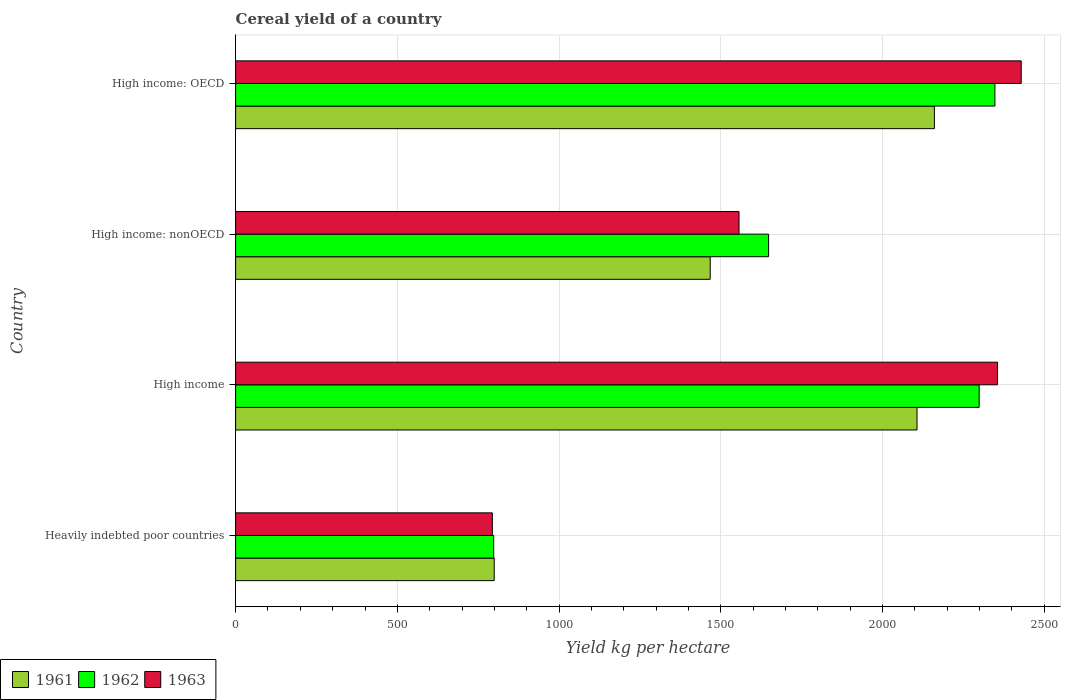How many different coloured bars are there?
Offer a terse response. 3. How many groups of bars are there?
Make the answer very short. 4. How many bars are there on the 1st tick from the top?
Provide a short and direct response. 3. How many bars are there on the 1st tick from the bottom?
Keep it short and to the point. 3. What is the label of the 4th group of bars from the top?
Offer a terse response. Heavily indebted poor countries. What is the total cereal yield in 1963 in High income?
Your response must be concise. 2355.41. Across all countries, what is the maximum total cereal yield in 1962?
Your answer should be very brief. 2347.24. Across all countries, what is the minimum total cereal yield in 1962?
Give a very brief answer. 797.81. In which country was the total cereal yield in 1962 maximum?
Keep it short and to the point. High income: OECD. In which country was the total cereal yield in 1963 minimum?
Make the answer very short. Heavily indebted poor countries. What is the total total cereal yield in 1963 in the graph?
Your answer should be compact. 7133.8. What is the difference between the total cereal yield in 1962 in Heavily indebted poor countries and that in High income?
Give a very brief answer. -1500.72. What is the difference between the total cereal yield in 1963 in High income and the total cereal yield in 1962 in High income: nonOECD?
Ensure brevity in your answer.  707.8. What is the average total cereal yield in 1961 per country?
Keep it short and to the point. 1633.28. What is the difference between the total cereal yield in 1963 and total cereal yield in 1961 in High income: OECD?
Your answer should be compact. 268.36. In how many countries, is the total cereal yield in 1962 greater than 2000 kg per hectare?
Make the answer very short. 2. What is the ratio of the total cereal yield in 1962 in Heavily indebted poor countries to that in High income: nonOECD?
Make the answer very short. 0.48. Is the difference between the total cereal yield in 1963 in High income: OECD and High income: nonOECD greater than the difference between the total cereal yield in 1961 in High income: OECD and High income: nonOECD?
Keep it short and to the point. Yes. What is the difference between the highest and the second highest total cereal yield in 1963?
Provide a short and direct response. 73.14. What is the difference between the highest and the lowest total cereal yield in 1963?
Provide a short and direct response. 1634.89. Are the values on the major ticks of X-axis written in scientific E-notation?
Ensure brevity in your answer.  No. Where does the legend appear in the graph?
Provide a succinct answer. Bottom left. How many legend labels are there?
Your response must be concise. 3. What is the title of the graph?
Your answer should be compact. Cereal yield of a country. Does "1962" appear as one of the legend labels in the graph?
Offer a terse response. Yes. What is the label or title of the X-axis?
Make the answer very short. Yield kg per hectare. What is the Yield kg per hectare in 1961 in Heavily indebted poor countries?
Offer a very short reply. 799.37. What is the Yield kg per hectare of 1962 in Heavily indebted poor countries?
Offer a very short reply. 797.81. What is the Yield kg per hectare in 1963 in Heavily indebted poor countries?
Ensure brevity in your answer.  793.65. What is the Yield kg per hectare of 1961 in High income?
Offer a terse response. 2106.44. What is the Yield kg per hectare in 1962 in High income?
Provide a short and direct response. 2298.54. What is the Yield kg per hectare in 1963 in High income?
Ensure brevity in your answer.  2355.41. What is the Yield kg per hectare of 1961 in High income: nonOECD?
Provide a succinct answer. 1467.13. What is the Yield kg per hectare in 1962 in High income: nonOECD?
Provide a succinct answer. 1647.61. What is the Yield kg per hectare of 1963 in High income: nonOECD?
Your answer should be compact. 1556.2. What is the Yield kg per hectare in 1961 in High income: OECD?
Ensure brevity in your answer.  2160.18. What is the Yield kg per hectare in 1962 in High income: OECD?
Your answer should be compact. 2347.24. What is the Yield kg per hectare in 1963 in High income: OECD?
Give a very brief answer. 2428.54. Across all countries, what is the maximum Yield kg per hectare of 1961?
Your answer should be compact. 2160.18. Across all countries, what is the maximum Yield kg per hectare of 1962?
Your response must be concise. 2347.24. Across all countries, what is the maximum Yield kg per hectare of 1963?
Make the answer very short. 2428.54. Across all countries, what is the minimum Yield kg per hectare in 1961?
Your answer should be very brief. 799.37. Across all countries, what is the minimum Yield kg per hectare of 1962?
Provide a short and direct response. 797.81. Across all countries, what is the minimum Yield kg per hectare of 1963?
Give a very brief answer. 793.65. What is the total Yield kg per hectare in 1961 in the graph?
Provide a short and direct response. 6533.12. What is the total Yield kg per hectare in 1962 in the graph?
Provide a succinct answer. 7091.2. What is the total Yield kg per hectare in 1963 in the graph?
Your response must be concise. 7133.8. What is the difference between the Yield kg per hectare in 1961 in Heavily indebted poor countries and that in High income?
Give a very brief answer. -1307.07. What is the difference between the Yield kg per hectare of 1962 in Heavily indebted poor countries and that in High income?
Your answer should be very brief. -1500.72. What is the difference between the Yield kg per hectare in 1963 in Heavily indebted poor countries and that in High income?
Your answer should be compact. -1561.76. What is the difference between the Yield kg per hectare of 1961 in Heavily indebted poor countries and that in High income: nonOECD?
Provide a short and direct response. -667.76. What is the difference between the Yield kg per hectare in 1962 in Heavily indebted poor countries and that in High income: nonOECD?
Provide a succinct answer. -849.8. What is the difference between the Yield kg per hectare of 1963 in Heavily indebted poor countries and that in High income: nonOECD?
Provide a succinct answer. -762.55. What is the difference between the Yield kg per hectare in 1961 in Heavily indebted poor countries and that in High income: OECD?
Offer a very short reply. -1360.81. What is the difference between the Yield kg per hectare of 1962 in Heavily indebted poor countries and that in High income: OECD?
Make the answer very short. -1549.43. What is the difference between the Yield kg per hectare in 1963 in Heavily indebted poor countries and that in High income: OECD?
Your answer should be very brief. -1634.89. What is the difference between the Yield kg per hectare in 1961 in High income and that in High income: nonOECD?
Keep it short and to the point. 639.31. What is the difference between the Yield kg per hectare in 1962 in High income and that in High income: nonOECD?
Ensure brevity in your answer.  650.93. What is the difference between the Yield kg per hectare in 1963 in High income and that in High income: nonOECD?
Give a very brief answer. 799.2. What is the difference between the Yield kg per hectare of 1961 in High income and that in High income: OECD?
Give a very brief answer. -53.74. What is the difference between the Yield kg per hectare of 1962 in High income and that in High income: OECD?
Your answer should be compact. -48.71. What is the difference between the Yield kg per hectare of 1963 in High income and that in High income: OECD?
Keep it short and to the point. -73.14. What is the difference between the Yield kg per hectare in 1961 in High income: nonOECD and that in High income: OECD?
Make the answer very short. -693.05. What is the difference between the Yield kg per hectare in 1962 in High income: nonOECD and that in High income: OECD?
Give a very brief answer. -699.63. What is the difference between the Yield kg per hectare in 1963 in High income: nonOECD and that in High income: OECD?
Give a very brief answer. -872.34. What is the difference between the Yield kg per hectare in 1961 in Heavily indebted poor countries and the Yield kg per hectare in 1962 in High income?
Offer a terse response. -1499.17. What is the difference between the Yield kg per hectare of 1961 in Heavily indebted poor countries and the Yield kg per hectare of 1963 in High income?
Your answer should be very brief. -1556.04. What is the difference between the Yield kg per hectare in 1962 in Heavily indebted poor countries and the Yield kg per hectare in 1963 in High income?
Offer a terse response. -1557.59. What is the difference between the Yield kg per hectare in 1961 in Heavily indebted poor countries and the Yield kg per hectare in 1962 in High income: nonOECD?
Give a very brief answer. -848.24. What is the difference between the Yield kg per hectare of 1961 in Heavily indebted poor countries and the Yield kg per hectare of 1963 in High income: nonOECD?
Your answer should be very brief. -756.83. What is the difference between the Yield kg per hectare of 1962 in Heavily indebted poor countries and the Yield kg per hectare of 1963 in High income: nonOECD?
Make the answer very short. -758.39. What is the difference between the Yield kg per hectare of 1961 in Heavily indebted poor countries and the Yield kg per hectare of 1962 in High income: OECD?
Make the answer very short. -1547.87. What is the difference between the Yield kg per hectare in 1961 in Heavily indebted poor countries and the Yield kg per hectare in 1963 in High income: OECD?
Offer a very short reply. -1629.17. What is the difference between the Yield kg per hectare in 1962 in Heavily indebted poor countries and the Yield kg per hectare in 1963 in High income: OECD?
Your response must be concise. -1630.73. What is the difference between the Yield kg per hectare in 1961 in High income and the Yield kg per hectare in 1962 in High income: nonOECD?
Keep it short and to the point. 458.83. What is the difference between the Yield kg per hectare in 1961 in High income and the Yield kg per hectare in 1963 in High income: nonOECD?
Give a very brief answer. 550.24. What is the difference between the Yield kg per hectare of 1962 in High income and the Yield kg per hectare of 1963 in High income: nonOECD?
Offer a terse response. 742.33. What is the difference between the Yield kg per hectare of 1961 in High income and the Yield kg per hectare of 1962 in High income: OECD?
Your response must be concise. -240.8. What is the difference between the Yield kg per hectare in 1961 in High income and the Yield kg per hectare in 1963 in High income: OECD?
Provide a short and direct response. -322.1. What is the difference between the Yield kg per hectare in 1962 in High income and the Yield kg per hectare in 1963 in High income: OECD?
Ensure brevity in your answer.  -130.01. What is the difference between the Yield kg per hectare of 1961 in High income: nonOECD and the Yield kg per hectare of 1962 in High income: OECD?
Provide a succinct answer. -880.11. What is the difference between the Yield kg per hectare of 1961 in High income: nonOECD and the Yield kg per hectare of 1963 in High income: OECD?
Offer a terse response. -961.41. What is the difference between the Yield kg per hectare of 1962 in High income: nonOECD and the Yield kg per hectare of 1963 in High income: OECD?
Offer a very short reply. -780.93. What is the average Yield kg per hectare of 1961 per country?
Provide a succinct answer. 1633.28. What is the average Yield kg per hectare of 1962 per country?
Ensure brevity in your answer.  1772.8. What is the average Yield kg per hectare of 1963 per country?
Make the answer very short. 1783.45. What is the difference between the Yield kg per hectare in 1961 and Yield kg per hectare in 1962 in Heavily indebted poor countries?
Offer a very short reply. 1.56. What is the difference between the Yield kg per hectare of 1961 and Yield kg per hectare of 1963 in Heavily indebted poor countries?
Offer a terse response. 5.72. What is the difference between the Yield kg per hectare of 1962 and Yield kg per hectare of 1963 in Heavily indebted poor countries?
Your response must be concise. 4.16. What is the difference between the Yield kg per hectare of 1961 and Yield kg per hectare of 1962 in High income?
Give a very brief answer. -192.09. What is the difference between the Yield kg per hectare of 1961 and Yield kg per hectare of 1963 in High income?
Keep it short and to the point. -248.96. What is the difference between the Yield kg per hectare of 1962 and Yield kg per hectare of 1963 in High income?
Your response must be concise. -56.87. What is the difference between the Yield kg per hectare in 1961 and Yield kg per hectare in 1962 in High income: nonOECD?
Ensure brevity in your answer.  -180.48. What is the difference between the Yield kg per hectare of 1961 and Yield kg per hectare of 1963 in High income: nonOECD?
Your answer should be very brief. -89.07. What is the difference between the Yield kg per hectare of 1962 and Yield kg per hectare of 1963 in High income: nonOECD?
Keep it short and to the point. 91.41. What is the difference between the Yield kg per hectare of 1961 and Yield kg per hectare of 1962 in High income: OECD?
Offer a very short reply. -187.06. What is the difference between the Yield kg per hectare of 1961 and Yield kg per hectare of 1963 in High income: OECD?
Ensure brevity in your answer.  -268.36. What is the difference between the Yield kg per hectare of 1962 and Yield kg per hectare of 1963 in High income: OECD?
Your response must be concise. -81.3. What is the ratio of the Yield kg per hectare of 1961 in Heavily indebted poor countries to that in High income?
Offer a very short reply. 0.38. What is the ratio of the Yield kg per hectare in 1962 in Heavily indebted poor countries to that in High income?
Keep it short and to the point. 0.35. What is the ratio of the Yield kg per hectare in 1963 in Heavily indebted poor countries to that in High income?
Provide a succinct answer. 0.34. What is the ratio of the Yield kg per hectare of 1961 in Heavily indebted poor countries to that in High income: nonOECD?
Your answer should be compact. 0.54. What is the ratio of the Yield kg per hectare of 1962 in Heavily indebted poor countries to that in High income: nonOECD?
Provide a short and direct response. 0.48. What is the ratio of the Yield kg per hectare in 1963 in Heavily indebted poor countries to that in High income: nonOECD?
Offer a terse response. 0.51. What is the ratio of the Yield kg per hectare of 1961 in Heavily indebted poor countries to that in High income: OECD?
Provide a short and direct response. 0.37. What is the ratio of the Yield kg per hectare of 1962 in Heavily indebted poor countries to that in High income: OECD?
Keep it short and to the point. 0.34. What is the ratio of the Yield kg per hectare in 1963 in Heavily indebted poor countries to that in High income: OECD?
Give a very brief answer. 0.33. What is the ratio of the Yield kg per hectare of 1961 in High income to that in High income: nonOECD?
Your answer should be compact. 1.44. What is the ratio of the Yield kg per hectare of 1962 in High income to that in High income: nonOECD?
Your response must be concise. 1.4. What is the ratio of the Yield kg per hectare of 1963 in High income to that in High income: nonOECD?
Provide a succinct answer. 1.51. What is the ratio of the Yield kg per hectare of 1961 in High income to that in High income: OECD?
Offer a terse response. 0.98. What is the ratio of the Yield kg per hectare in 1962 in High income to that in High income: OECD?
Give a very brief answer. 0.98. What is the ratio of the Yield kg per hectare of 1963 in High income to that in High income: OECD?
Your answer should be very brief. 0.97. What is the ratio of the Yield kg per hectare in 1961 in High income: nonOECD to that in High income: OECD?
Provide a short and direct response. 0.68. What is the ratio of the Yield kg per hectare of 1962 in High income: nonOECD to that in High income: OECD?
Keep it short and to the point. 0.7. What is the ratio of the Yield kg per hectare of 1963 in High income: nonOECD to that in High income: OECD?
Your response must be concise. 0.64. What is the difference between the highest and the second highest Yield kg per hectare in 1961?
Provide a succinct answer. 53.74. What is the difference between the highest and the second highest Yield kg per hectare in 1962?
Keep it short and to the point. 48.71. What is the difference between the highest and the second highest Yield kg per hectare of 1963?
Ensure brevity in your answer.  73.14. What is the difference between the highest and the lowest Yield kg per hectare in 1961?
Your answer should be very brief. 1360.81. What is the difference between the highest and the lowest Yield kg per hectare of 1962?
Your answer should be compact. 1549.43. What is the difference between the highest and the lowest Yield kg per hectare in 1963?
Offer a terse response. 1634.89. 